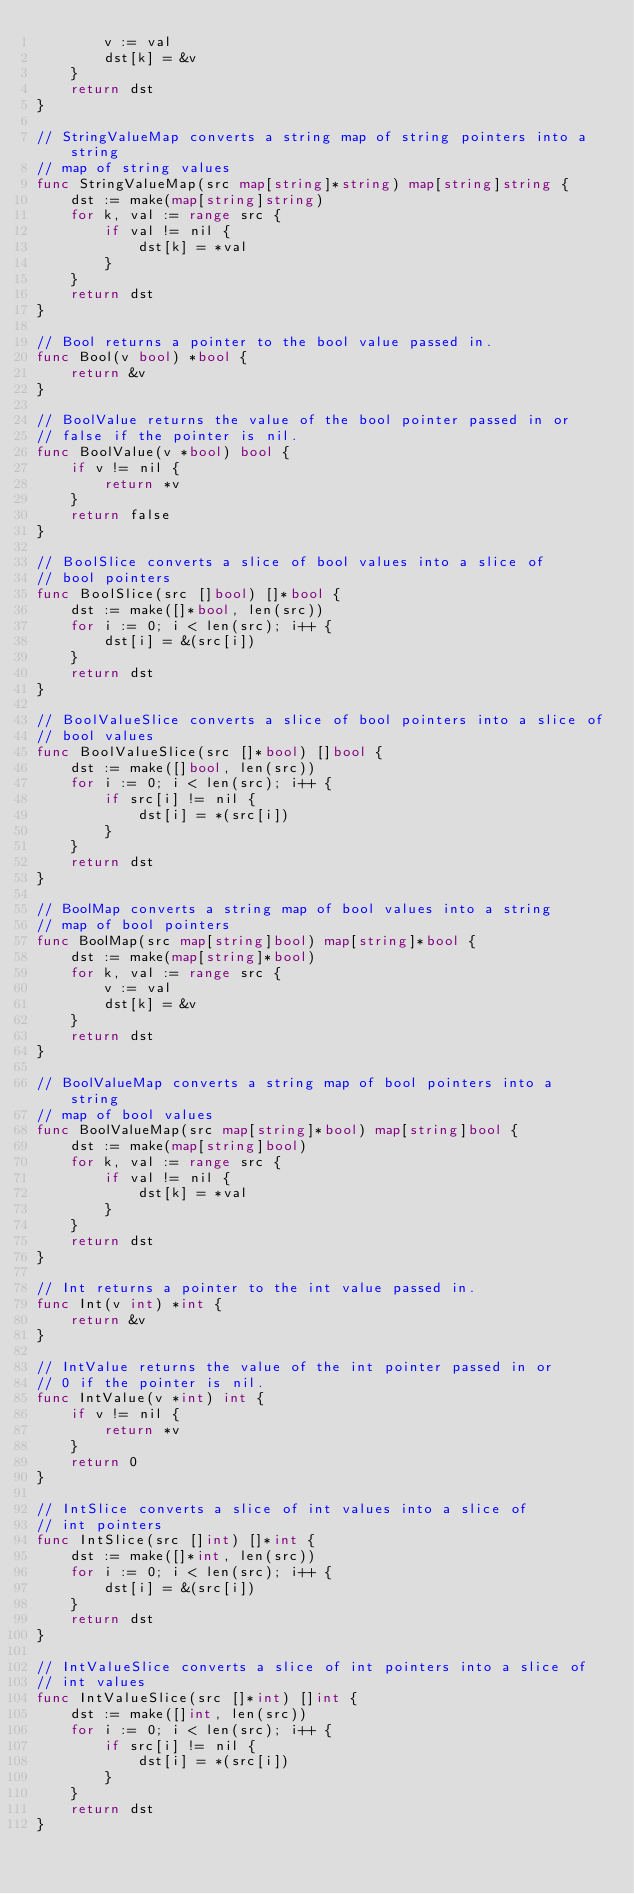Convert code to text. <code><loc_0><loc_0><loc_500><loc_500><_Go_>		v := val
		dst[k] = &v
	}
	return dst
}

// StringValueMap converts a string map of string pointers into a string
// map of string values
func StringValueMap(src map[string]*string) map[string]string {
	dst := make(map[string]string)
	for k, val := range src {
		if val != nil {
			dst[k] = *val
		}
	}
	return dst
}

// Bool returns a pointer to the bool value passed in.
func Bool(v bool) *bool {
	return &v
}

// BoolValue returns the value of the bool pointer passed in or
// false if the pointer is nil.
func BoolValue(v *bool) bool {
	if v != nil {
		return *v
	}
	return false
}

// BoolSlice converts a slice of bool values into a slice of
// bool pointers
func BoolSlice(src []bool) []*bool {
	dst := make([]*bool, len(src))
	for i := 0; i < len(src); i++ {
		dst[i] = &(src[i])
	}
	return dst
}

// BoolValueSlice converts a slice of bool pointers into a slice of
// bool values
func BoolValueSlice(src []*bool) []bool {
	dst := make([]bool, len(src))
	for i := 0; i < len(src); i++ {
		if src[i] != nil {
			dst[i] = *(src[i])
		}
	}
	return dst
}

// BoolMap converts a string map of bool values into a string
// map of bool pointers
func BoolMap(src map[string]bool) map[string]*bool {
	dst := make(map[string]*bool)
	for k, val := range src {
		v := val
		dst[k] = &v
	}
	return dst
}

// BoolValueMap converts a string map of bool pointers into a string
// map of bool values
func BoolValueMap(src map[string]*bool) map[string]bool {
	dst := make(map[string]bool)
	for k, val := range src {
		if val != nil {
			dst[k] = *val
		}
	}
	return dst
}

// Int returns a pointer to the int value passed in.
func Int(v int) *int {
	return &v
}

// IntValue returns the value of the int pointer passed in or
// 0 if the pointer is nil.
func IntValue(v *int) int {
	if v != nil {
		return *v
	}
	return 0
}

// IntSlice converts a slice of int values into a slice of
// int pointers
func IntSlice(src []int) []*int {
	dst := make([]*int, len(src))
	for i := 0; i < len(src); i++ {
		dst[i] = &(src[i])
	}
	return dst
}

// IntValueSlice converts a slice of int pointers into a slice of
// int values
func IntValueSlice(src []*int) []int {
	dst := make([]int, len(src))
	for i := 0; i < len(src); i++ {
		if src[i] != nil {
			dst[i] = *(src[i])
		}
	}
	return dst
}
</code> 